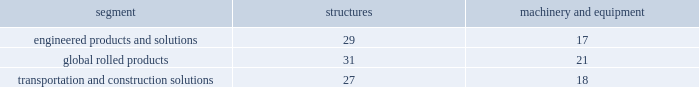Arconic and subsidiaries notes to the consolidated financial statements ( dollars in millions , except per-share amounts ) a .
Summary of significant accounting policies basis of presentation .
The consolidated financial statements of arconic inc .
And subsidiaries ( 201carconic 201d or the 201ccompany 201d ) are prepared in conformity with accounting principles generally accepted in the united states of america ( gaap ) and require management to make certain judgments , estimates , and assumptions .
These may affect the reported amounts of assets and liabilities and the disclosure of contingent assets and liabilities at the date of the financial statements .
They also may affect the reported amounts of revenues and expenses during the reporting period .
Actual results could differ from those estimates upon subsequent resolution of identified matters .
Certain prior year amounts have been reclassified to conform to the current year presentation .
The separation of alcoa inc .
Into two standalone , publicly-traded companies , arconic inc .
( the new name for alcoa inc. ) and alcoa corporation , became effective on november 1 , 2016 ( the 201cseparation transaction 201d ) .
The financial results of alcoa corporation for all periods prior to the separation transaction have been retrospectively reflected in the statement of consolidated operations as discontinued operations and , as such , have been excluded from continuing operations and segment results for all periods presented prior to the separation transaction .
The cash flows and comprehensive income related to alcoa corporation have not been segregated and are included in the statement of consolidated cash flows and statement of consolidated comprehensive ( loss ) income , respectively , for all periods presented .
See note c for additional information related to the separation transaction and discontinued operations .
Principles of consolidation .
The consolidated financial statements include the accounts of arconic and companies in which arconic has a controlling interest .
Intercompany transactions have been eliminated .
Investments in affiliates in which arconic cannot exercise significant influence are accounted for on the cost method .
Management also evaluates whether an arconic entity or interest is a variable interest entity and whether arconic is the primary beneficiary .
Consolidation is required if both of these criteria are met .
Arconic does not have any variable interest entities requiring consolidation .
Related party transactions .
Arconic buys products from and provides services to alcoa corporation following the separation at negotiated prices between the parties .
These transactions were not material to the financial position or results of operations of arconic for all periods presented .
Effective may 2017 , upon disposition of the remaining common stock that arconic held in alcoa corporation , they are no longer deemed a related party .
Cash equivalents .
Cash equivalents are highly liquid investments purchased with an original maturity of three months or less .
Inventory valuation .
Inventories are carried at the lower of cost and net realizable value , with cost for approximately half of u.s .
Inventories determined under the last-in , first-out ( lifo ) method .
The cost of other inventories is determined under a combination of the first-in , first-out ( fifo ) and average-cost methods .
Properties , plants , and equipment .
Properties , plants , and equipment are recorded at cost .
Depreciation is recorded principally on the straight-line method at rates based on the estimated useful lives of the assets .
The table details the weighted-average useful lives of structures and machinery and equipment by reporting segment ( numbers in years ) : .
Gains or losses from the sale of assets are generally recorded in other income , net ( see policy below for assets classified as held for sale and discontinued operations ) .
Repairs and maintenance are charged to expense as incurred .
Interest related to the construction of qualifying assets is capitalized as part of the construction costs .
Properties , plants , and equipment are reviewed for impairment whenever events or changes in circumstances indicate that the carrying amount of such assets ( asset group ) may not be recoverable .
Recoverability of assets is determined by comparing the estimated undiscounted net cash flows of the operations related to the assets ( asset group ) to their carrying amount .
An impairment loss would be recognized when the carrying amount of the assets ( asset group ) exceeds the estimated undiscounted net cash flows .
The amount of the impairment loss to be recorded is calculated as the excess of the carrying value of the assets .
What is the variation between the useful lives of the structures and machinery and equipment by the global rolled products segment? 
Rationale: it is the difference between the number of years .
Computations: (31 - 21)
Answer: 10.0. 